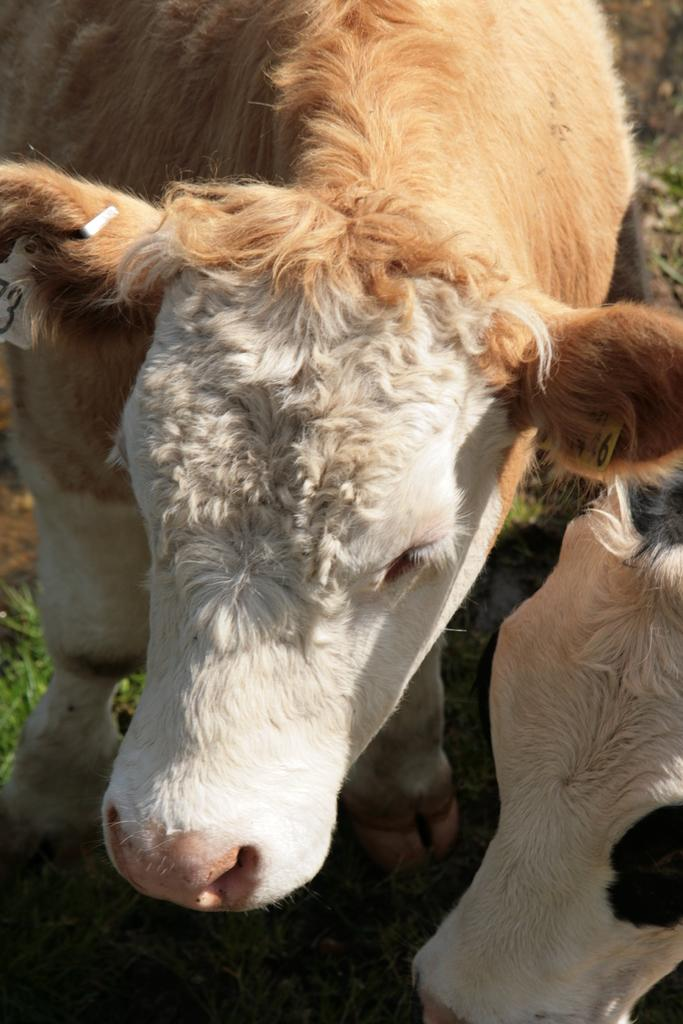What type of living organisms can be seen in the image? There are animals in the image. Where are the animals located? The animals are on a grassland. What type of news can be heard coming from the animals in the image? There is no indication in the image that the animals are making any sounds, let alone news. 